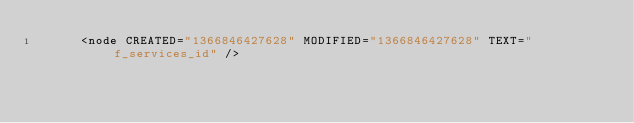<code> <loc_0><loc_0><loc_500><loc_500><_ObjectiveC_>      <node CREATED="1366846427628" MODIFIED="1366846427628" TEXT="f_services_id" /></code> 